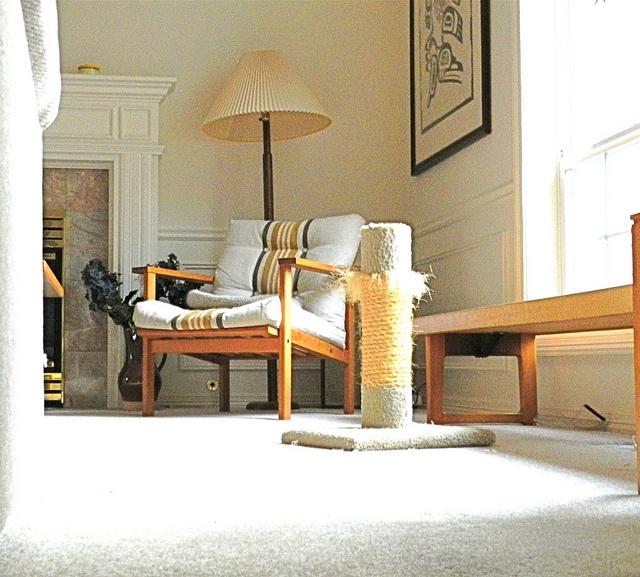Describe the objects in this image and their specific colors. I can see chair in ivory, white, gray, darkgray, and tan tones, couch in ivory, white, darkgray, lightgray, and black tones, potted plant in ivory, black, gray, and maroon tones, and vase in ivory, black, and gray tones in this image. 